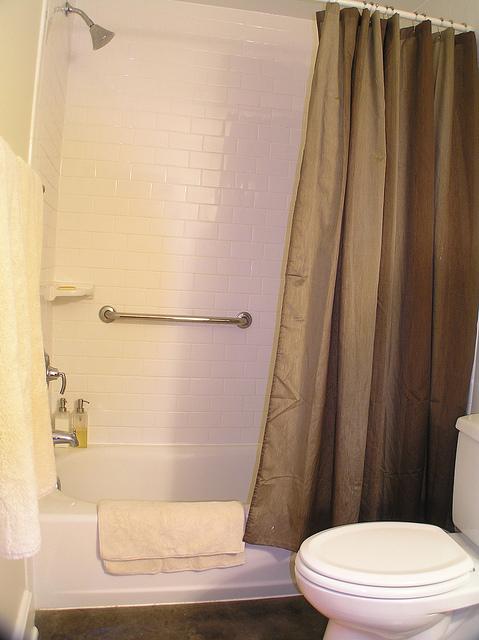What color is the shower curtain?
Keep it brief. Brown. Is the shower wall white or black?
Keep it brief. White. How many bottles are in the shower?
Write a very short answer. 2. 